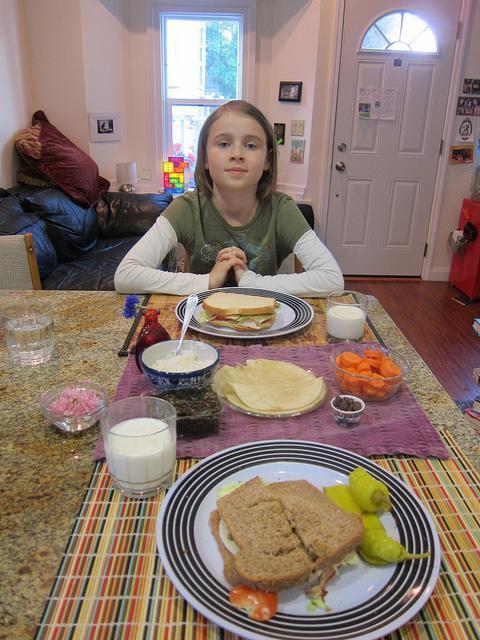How many cups are there?
Give a very brief answer. 3. How many bowls are there?
Give a very brief answer. 3. How many sandwiches are in the picture?
Give a very brief answer. 2. 